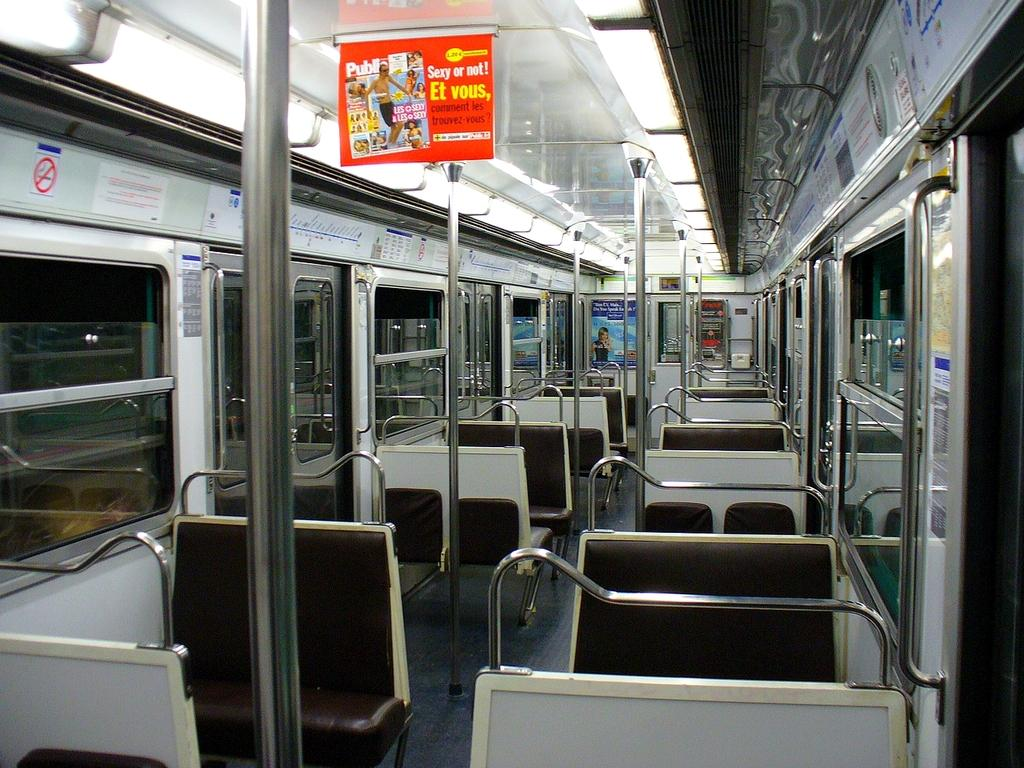<image>
Write a terse but informative summary of the picture. An advertisement for a magazine hangs from the interior of a subway car and asks "Sexy or not!" 